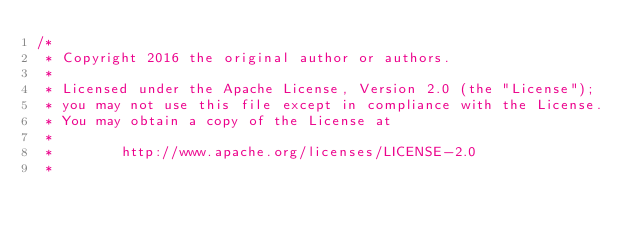Convert code to text. <code><loc_0><loc_0><loc_500><loc_500><_Java_>/*
 * Copyright 2016 the original author or authors.
 *
 * Licensed under the Apache License, Version 2.0 (the "License");
 * you may not use this file except in compliance with the License.
 * You may obtain a copy of the License at
 *
 *        http://www.apache.org/licenses/LICENSE-2.0
 *</code> 